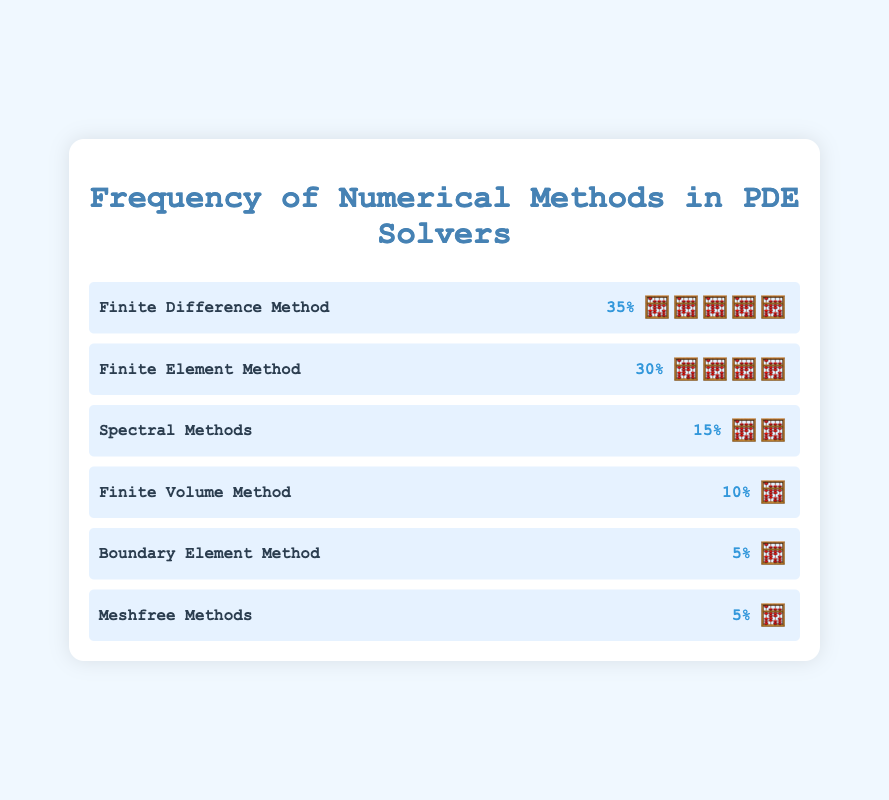What is the most frequently used numerical method? The method with the highest frequency is the Finite Difference Method, which is indicated by 5 calculator emojis.
Answer: Finite Difference Method Which method has the lowest frequency? The Boundary Element Method and Meshfree Methods both have the lowest frequencies, each with 1 calculator emoji.
Answer: Boundary Element Method and Meshfree Methods How many methods have a frequency of 10% or more? The methods are Finite Difference Method (35%), Finite Element Method (30%), Spectral Methods (15%), and Finite Volume Method (10%). This totals to 4 methods.
Answer: 4 What is the combined frequency of Boundary Element Method and Meshfree Methods? Each method has a frequency of 5%. Adding them together gives 5% + 5% = 10%.
Answer: 10% Which method has a frequency twice that of Finite Volume Method? The Finite Volume Method has a frequency of 10%. Twice this value is 20%, but no method has exactly 20% frequency; the closest higher frequency is Spectral Methods with 15%.
Answer: None How many more calculator emojis does the Finite Difference Method have compared to Spectral Methods? The Finite Difference Method has 5 emojis, while Spectral Methods has 2 emojis. The difference is 5 - 2 = 3 emojis.
Answer: 3 Among the listed methods, which has the second highest frequency? The Finite Difference Method is the highest, and the Finite Element Method comes second with 30% frequency shown by 4 emojis.
Answer: Finite Element Method If Finite Element Method's frequency was increased by 10%, what would its new frequency be? Currently, the Finite Element Method has a frequency of 30%. Increasing it by 10%, its new frequency would be 30% + 10% = 40%.
Answer: 40% What is the average frequency of all the methods listed? Sum all frequencies (35 + 30 + 15 + 10 + 5 + 5 = 100). There are 6 methods. Therefore, the average frequency is 100/6 = approximately 16.67%.
Answer: 16.67% 